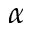<formula> <loc_0><loc_0><loc_500><loc_500>\alpha</formula> 